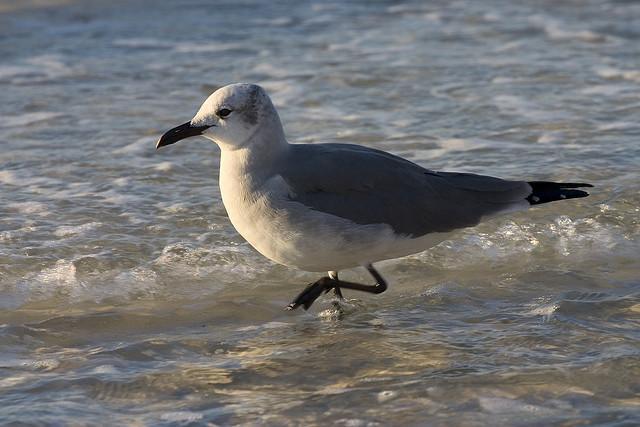How many feet are in the water?
Give a very brief answer. 1. 